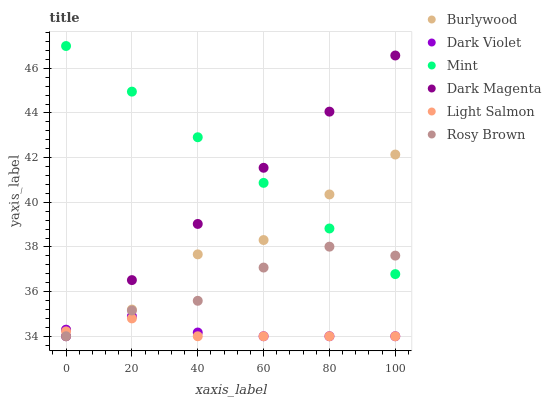Does Light Salmon have the minimum area under the curve?
Answer yes or no. Yes. Does Mint have the maximum area under the curve?
Answer yes or no. Yes. Does Dark Magenta have the minimum area under the curve?
Answer yes or no. No. Does Dark Magenta have the maximum area under the curve?
Answer yes or no. No. Is Dark Magenta the smoothest?
Answer yes or no. Yes. Is Burlywood the roughest?
Answer yes or no. Yes. Is Burlywood the smoothest?
Answer yes or no. No. Is Dark Magenta the roughest?
Answer yes or no. No. Does Light Salmon have the lowest value?
Answer yes or no. Yes. Does Burlywood have the lowest value?
Answer yes or no. No. Does Mint have the highest value?
Answer yes or no. Yes. Does Dark Magenta have the highest value?
Answer yes or no. No. Is Light Salmon less than Mint?
Answer yes or no. Yes. Is Burlywood greater than Rosy Brown?
Answer yes or no. Yes. Does Burlywood intersect Mint?
Answer yes or no. Yes. Is Burlywood less than Mint?
Answer yes or no. No. Is Burlywood greater than Mint?
Answer yes or no. No. Does Light Salmon intersect Mint?
Answer yes or no. No. 